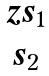<formula> <loc_0><loc_0><loc_500><loc_500>\begin{matrix} z s _ { 1 } \\ s _ { 2 } \end{matrix}</formula> 